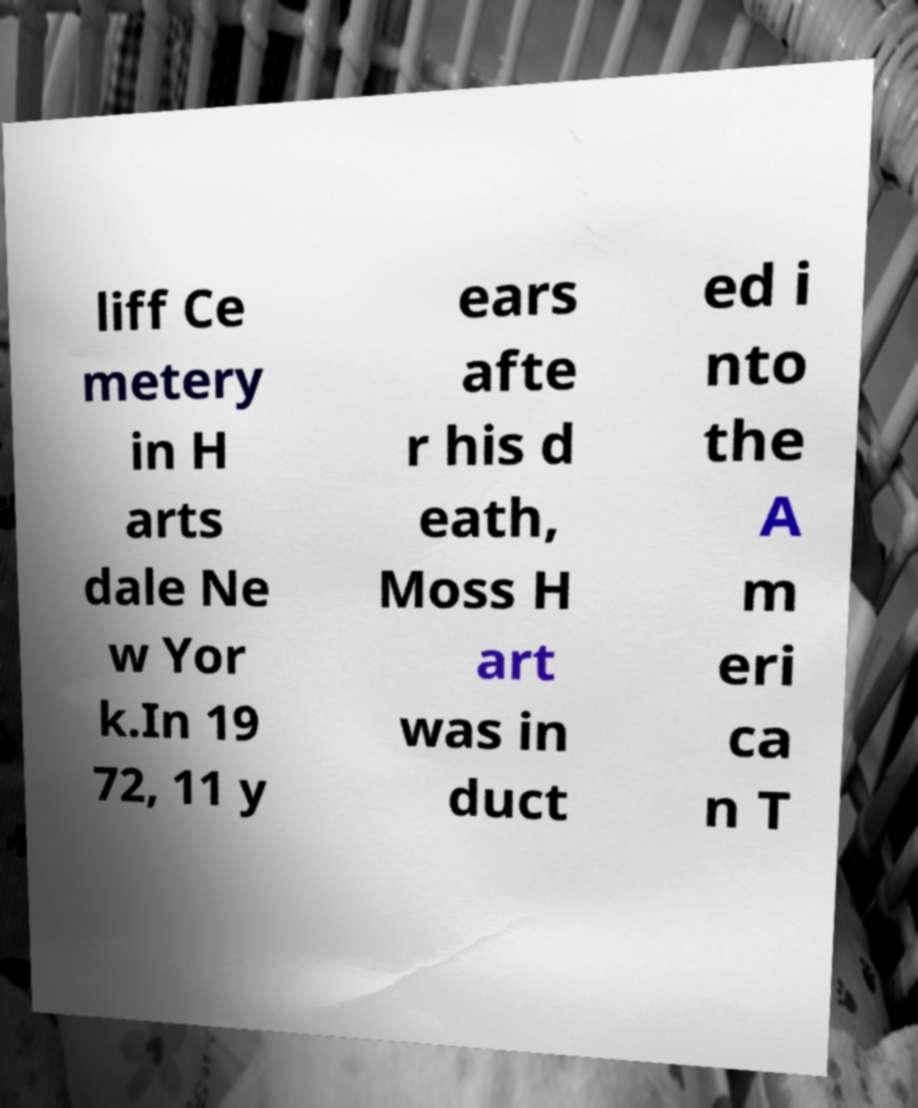I need the written content from this picture converted into text. Can you do that? liff Ce metery in H arts dale Ne w Yor k.In 19 72, 11 y ears afte r his d eath, Moss H art was in duct ed i nto the A m eri ca n T 